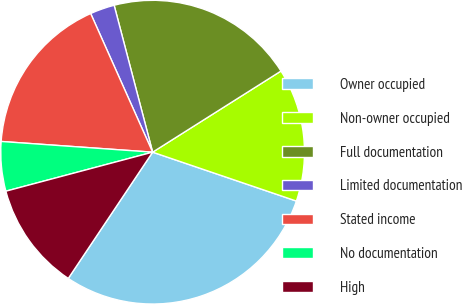Convert chart. <chart><loc_0><loc_0><loc_500><loc_500><pie_chart><fcel>Owner occupied<fcel>Non-owner occupied<fcel>Full documentation<fcel>Limited documentation<fcel>Stated income<fcel>No documentation<fcel>High<nl><fcel>29.16%<fcel>14.19%<fcel>20.11%<fcel>2.61%<fcel>17.19%<fcel>5.26%<fcel>11.49%<nl></chart> 